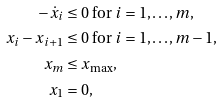<formula> <loc_0><loc_0><loc_500><loc_500>- \dot { x } _ { i } & \leq 0 \text { for } i = 1 , \dots , m , \\ x _ { i } - x _ { i + 1 } & \leq 0 \text { for } i = 1 , \dots , m - 1 , \\ x _ { m } & \leq x _ { \max } , \\ x _ { 1 } & = 0 ,</formula> 